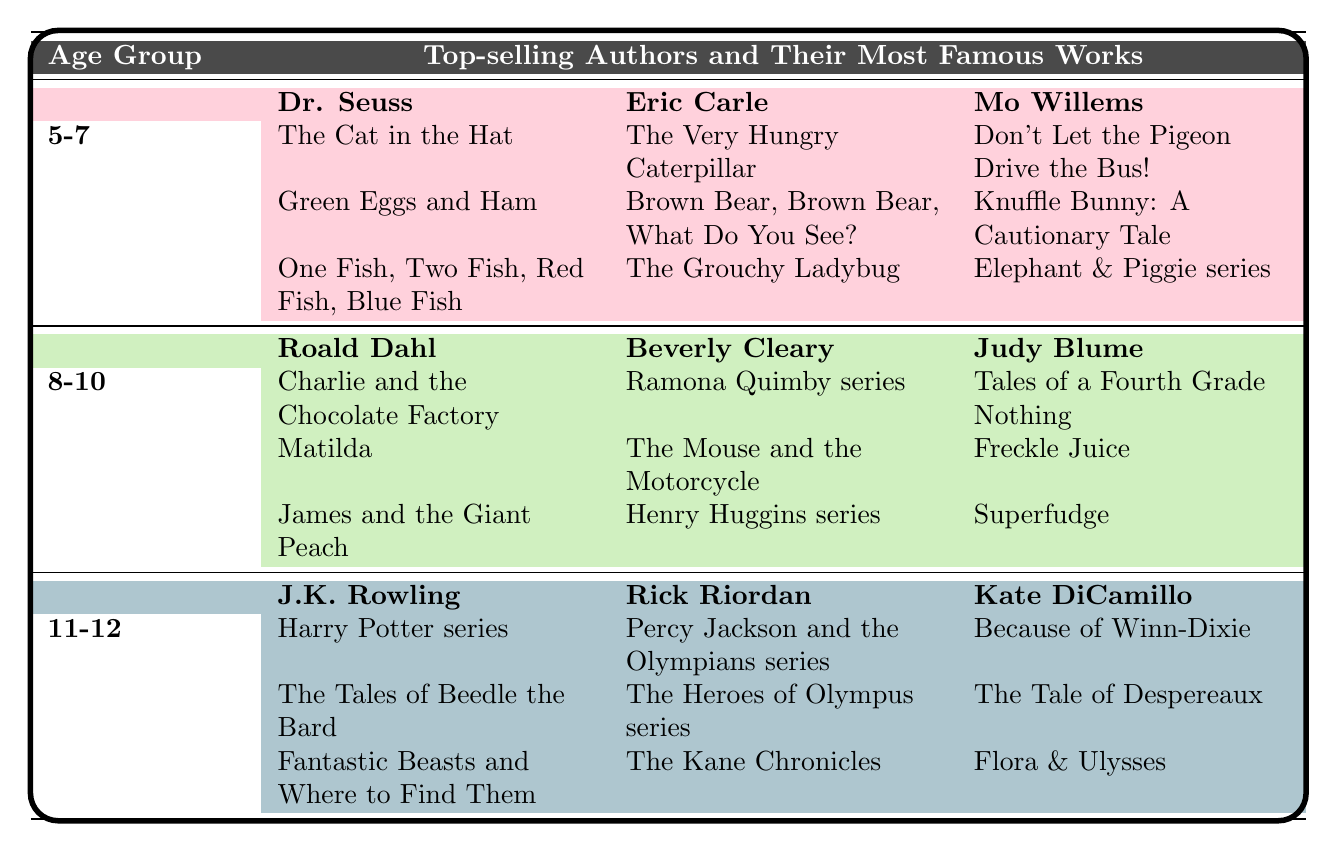What are some famous books by Dr. Seuss? Dr. Seuss is listed under the age group 5-7, and the table shows three of his famous works: "The Cat in the Hat," "Green Eggs and Ham," and "One Fish, Two Fish, Red Fish, Blue Fish."
Answer: "The Cat in the Hat," "Green Eggs and Ham," "One Fish, Two Fish, Red Fish, Blue Fish" Which author has the most famous books for the age group 8-10? The table has three authors listed for the 8-10 age group, mentioning Roald Dahl, Beverly Cleary, and Judy Blume with their most notable works. Roald Dahl is known for three well-known books: "Charlie and the Chocolate Factory," "Matilda," and "James and the Giant Peach." This indicates he is a prominent author within that age group.
Answer: Roald Dahl Are there any books by J.K. Rowling mentioned in the table? Yes, J.K. Rowling is listed as an author in the age group 11-12, and the table includes "Harry Potter series," "The Tales of Beedle the Bard," and "Fantastic Beasts and Where to Find Them" under her name.
Answer: Yes How many famous works are listed for Beverly Cleary? Beverly Cleary has three famous works listed in the 8-10 age group: "Ramona Quimby series," "The Mouse and the Motorcycle," and "Henry Huggins series."
Answer: 3 Are there more books listed for age group 11-12 than for age group 8-10? Each age group has three authors, and each author has three works listed. Therefore, both age groups have the same number of total works, which is 9 for age group 11-12 and 9 for age group 8-10.
Answer: No Which age group has the least number of authors listed? The age group 5-7 has fewer authors compared to the other age groups with three total authors: Dr. Seuss, Eric Carle, and Mo Willems, whereas age groups 8-10 and 11-12 both have three authors. This indicates equal representation and no lesser number of authors.
Answer: None Count the total number of unique authors mentioned in the table. There are a total of 9 unique authors across the three age groups. This is calculated by counting each author listed for the respective age groups: 3 for ages 5-7, 3 for ages 8-10, and 3 for ages 11-12.
Answer: 9 Is "Matilda" the only famous book for Roald Dahl in the table? No, Roald Dahl has three famous works listed: "Charlie and the Chocolate Factory," "Matilda," and "James and the Giant Peach." Hence, "Matilda" is not the only title attributed to him in the table.
Answer: No Who are the authors listed for the age group 11-12? The authors listed for the age group 11-12 are J.K. Rowling, Rick Riordan, and Kate DiCamillo. This information can be extracted directly from the corresponding section of the table.
Answer: J.K. Rowling, Rick Riordan, Kate DiCamillo Which author has the most titles in the table across all age groups? Each author listed in the table has three titles attributed to them, which are the same for each author in their respective age group. Therefore, there isn't an author with more titles than another across the table.
Answer: None, all authors have 3 titles 